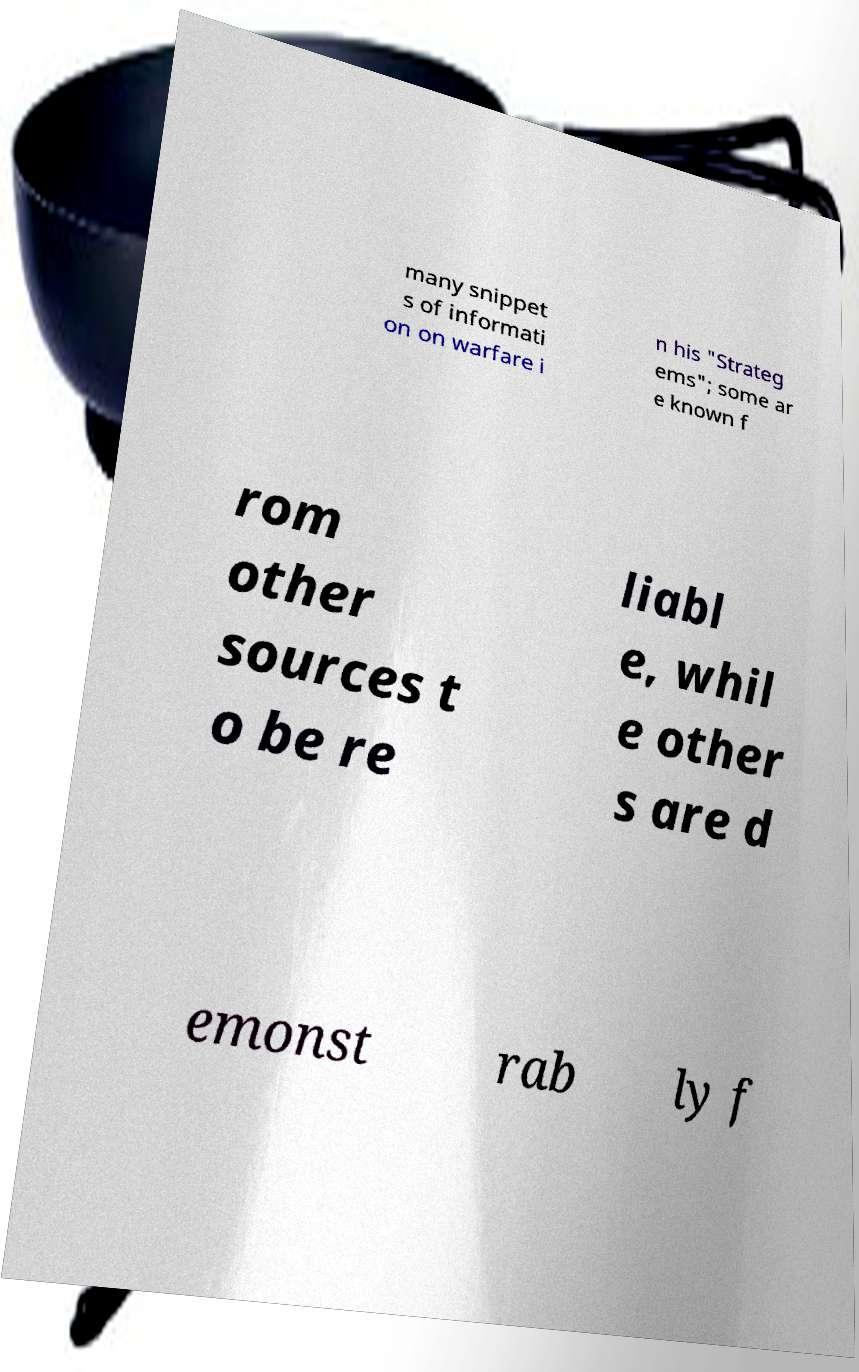Can you accurately transcribe the text from the provided image for me? many snippet s of informati on on warfare i n his "Strateg ems"; some ar e known f rom other sources t o be re liabl e, whil e other s are d emonst rab ly f 